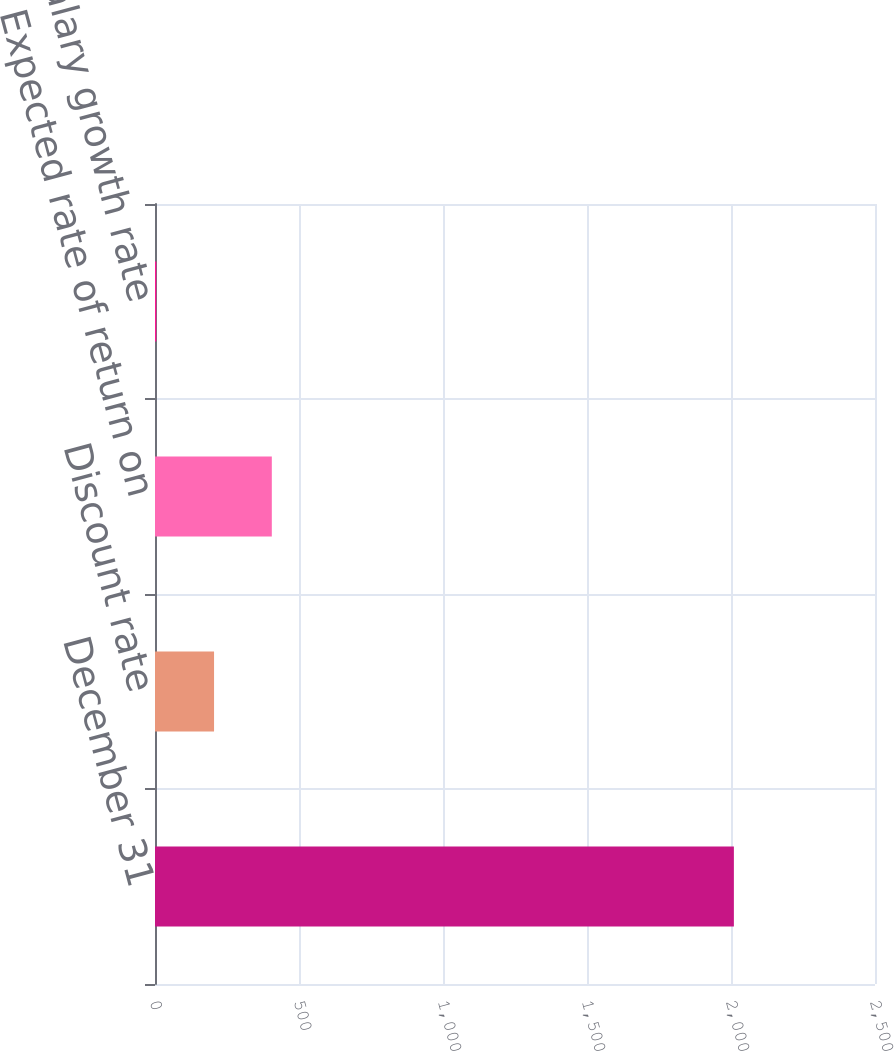Convert chart to OTSL. <chart><loc_0><loc_0><loc_500><loc_500><bar_chart><fcel>December 31<fcel>Discount rate<fcel>Expected rate of return on<fcel>Salary growth rate<nl><fcel>2010<fcel>205.05<fcel>405.6<fcel>4.5<nl></chart> 